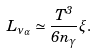Convert formula to latex. <formula><loc_0><loc_0><loc_500><loc_500>L _ { \nu _ { \alpha } } \simeq \frac { T ^ { 3 } } { 6 n _ { \gamma } } \xi .</formula> 